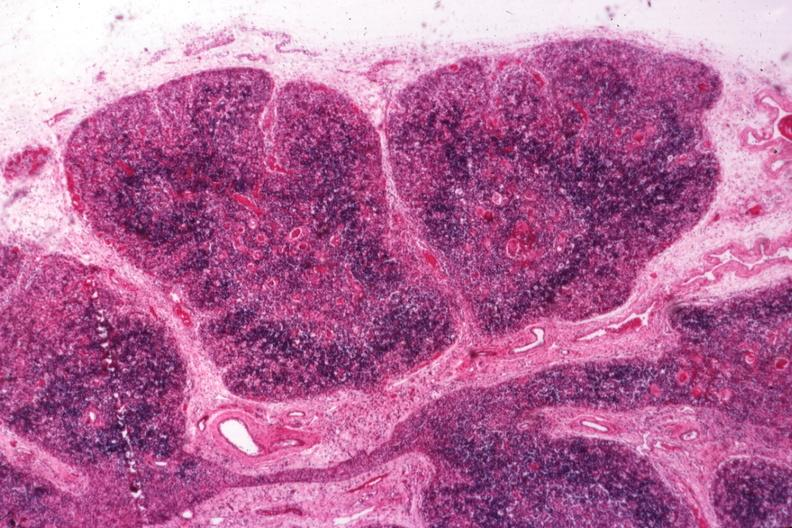does this image show typical atrophy associated with infection in newborn?
Answer the question using a single word or phrase. Yes 